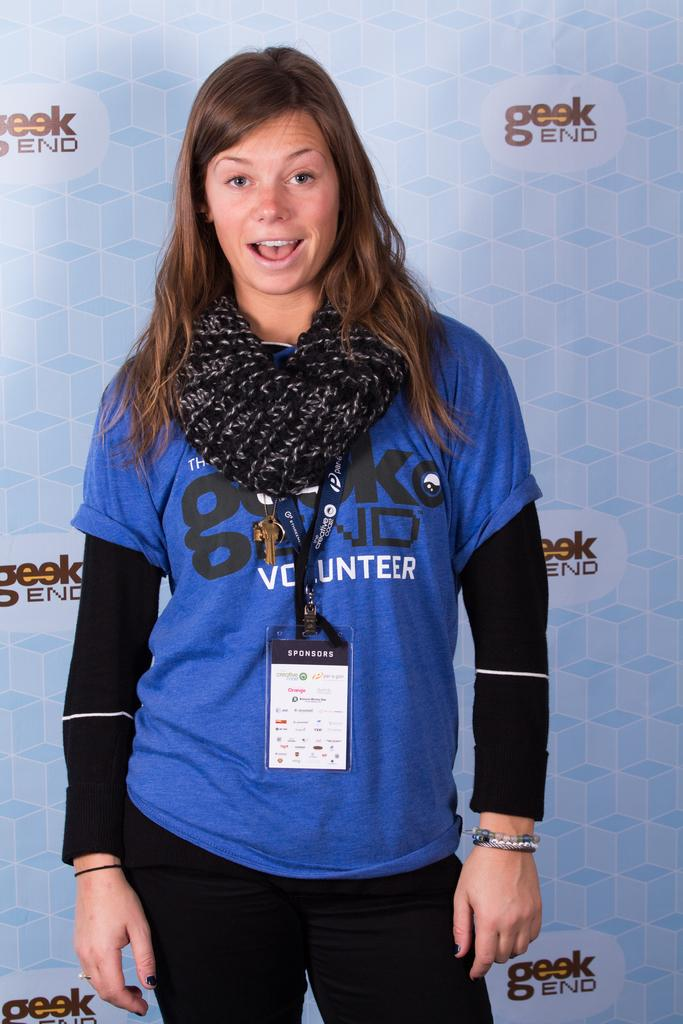What is the main subject of the image? There is a person standing in the image. Can you describe the background of the image? The background of the image consists of text and design. How many ducks are visible in the image? There are no ducks present in the image. What type of desk is the person using in the image? There is no desk visible in the image. 